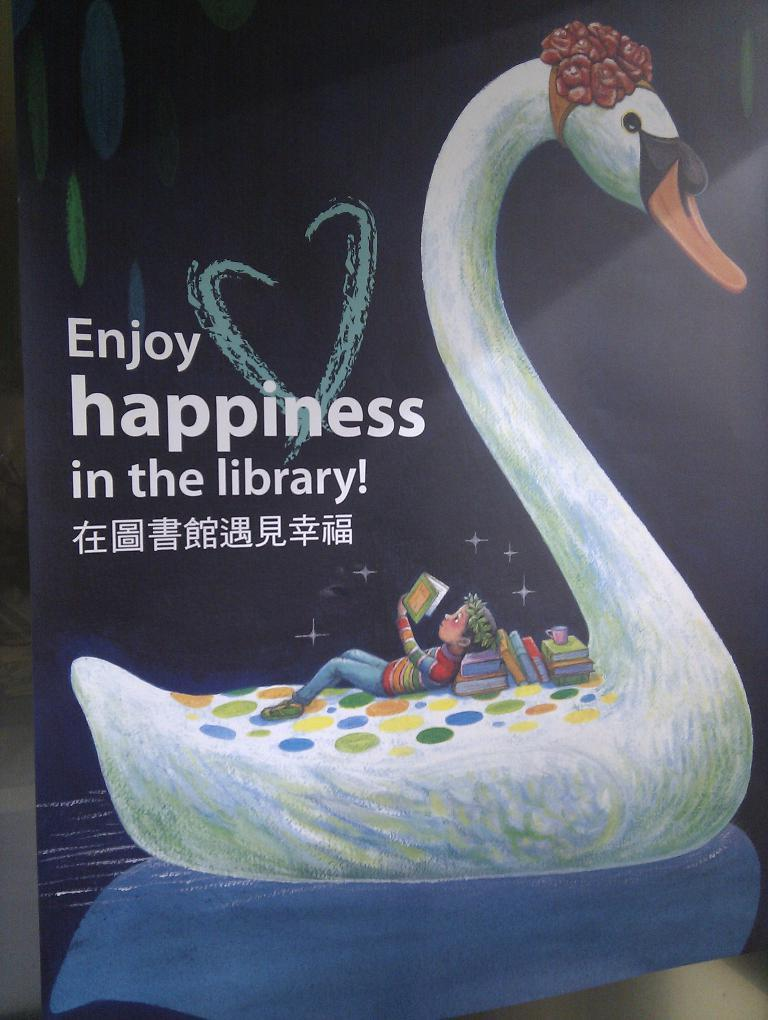Who is the main subject in the picture? There is a boy in the picture. What is the boy doing in the picture? The boy is lying on a swan and reading books. Are there any other books visible in the picture? Yes, there are additional books in the picture. Can you describe the cover page of a book that is visible in the image? There is a cover page of a book visible in the image. What type of berry is the boy holding in the picture? There is no berry present in the image; the boy is reading books while lying on a swan. 